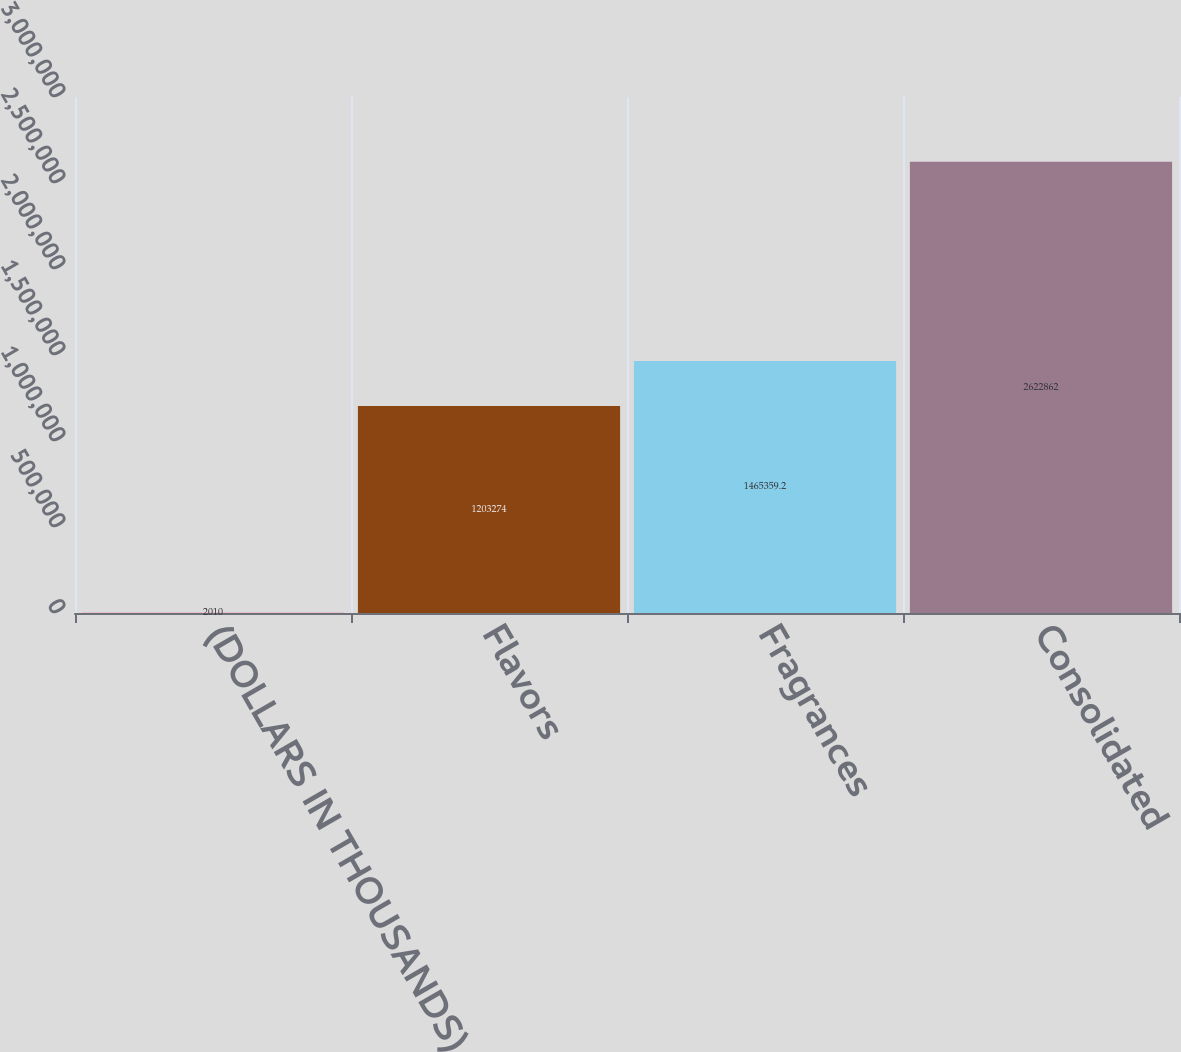<chart> <loc_0><loc_0><loc_500><loc_500><bar_chart><fcel>(DOLLARS IN THOUSANDS)<fcel>Flavors<fcel>Fragrances<fcel>Consolidated<nl><fcel>2010<fcel>1.20327e+06<fcel>1.46536e+06<fcel>2.62286e+06<nl></chart> 